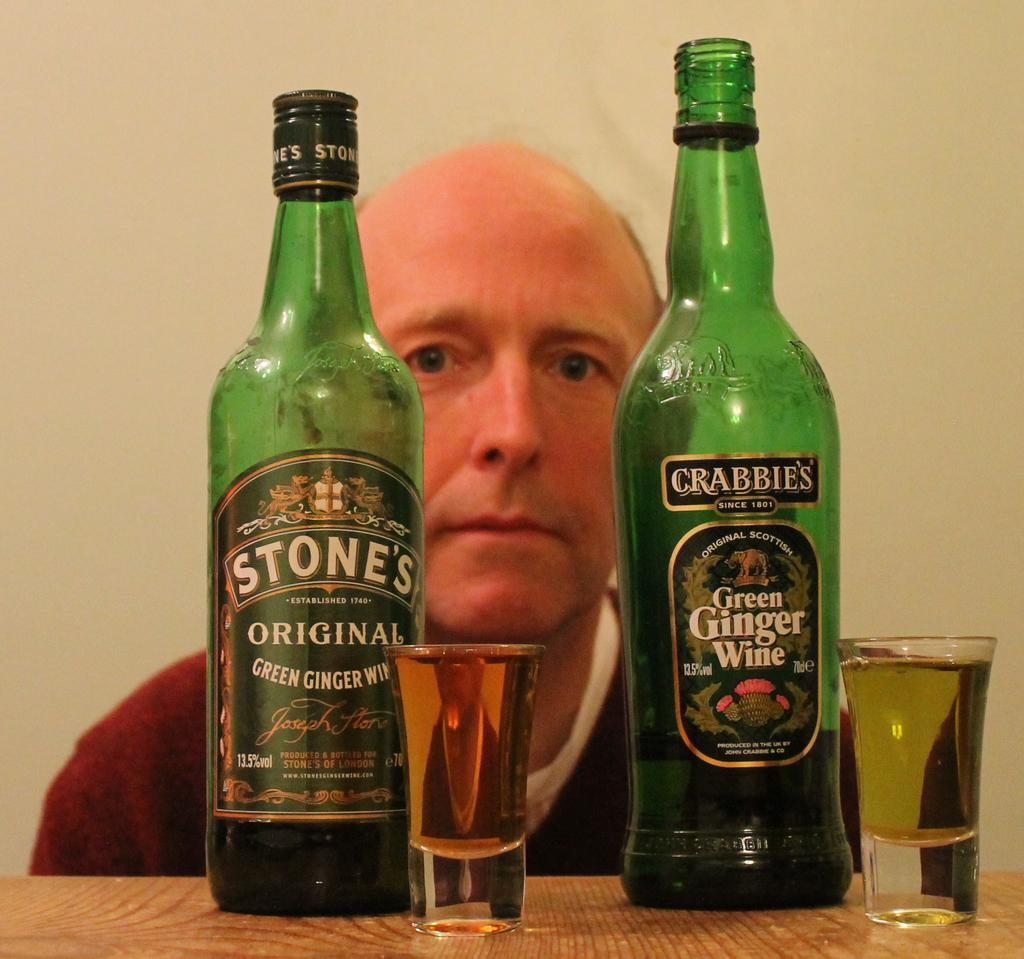<image>
Give a short and clear explanation of the subsequent image. Two green glass bottles of Green Ginger Wine. 